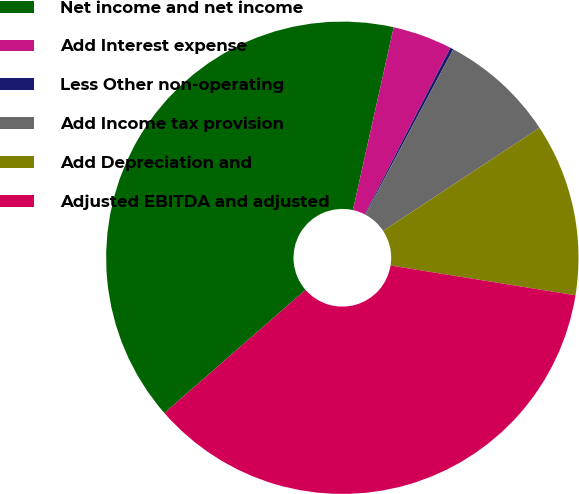Convert chart to OTSL. <chart><loc_0><loc_0><loc_500><loc_500><pie_chart><fcel>Net income and net income<fcel>Add Interest expense<fcel>Less Other non-operating<fcel>Add Income tax provision<fcel>Add Depreciation and<fcel>Adjusted EBITDA and adjusted<nl><fcel>39.91%<fcel>4.08%<fcel>0.21%<fcel>7.95%<fcel>11.81%<fcel>36.04%<nl></chart> 